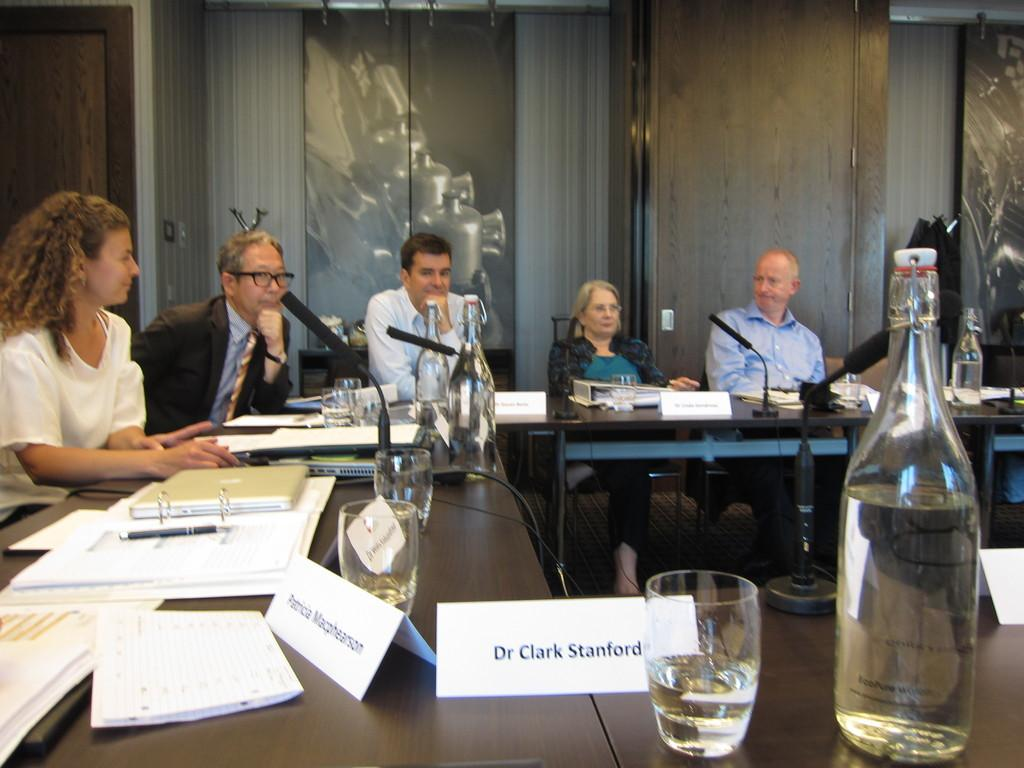How many people are sitting in the image? There are five people sitting on chairs in the image. What objects can be seen on the table? There is a laptop, a book, a pen, a glass, and a bottle on the table. What additional item is present in the image? There is a microphone (mic) in the image. What is the purpose of the park in the image? There is no park present in the image; it features people sitting on chairs, a table with various objects, and a microphone. 